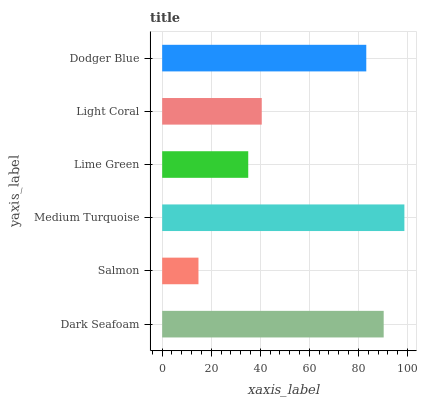Is Salmon the minimum?
Answer yes or no. Yes. Is Medium Turquoise the maximum?
Answer yes or no. Yes. Is Medium Turquoise the minimum?
Answer yes or no. No. Is Salmon the maximum?
Answer yes or no. No. Is Medium Turquoise greater than Salmon?
Answer yes or no. Yes. Is Salmon less than Medium Turquoise?
Answer yes or no. Yes. Is Salmon greater than Medium Turquoise?
Answer yes or no. No. Is Medium Turquoise less than Salmon?
Answer yes or no. No. Is Dodger Blue the high median?
Answer yes or no. Yes. Is Light Coral the low median?
Answer yes or no. Yes. Is Medium Turquoise the high median?
Answer yes or no. No. Is Dodger Blue the low median?
Answer yes or no. No. 